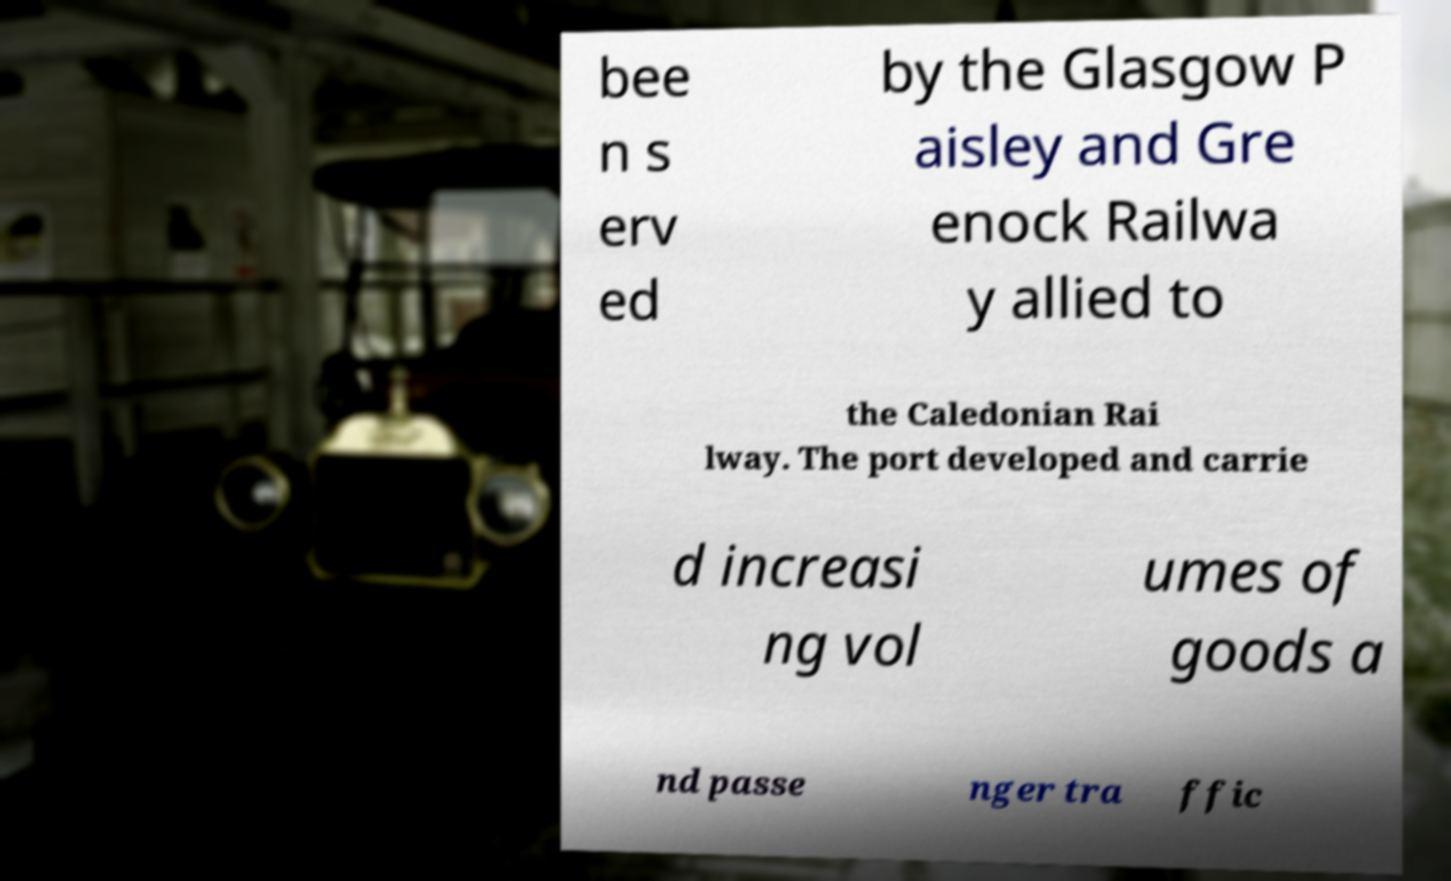Please identify and transcribe the text found in this image. bee n s erv ed by the Glasgow P aisley and Gre enock Railwa y allied to the Caledonian Rai lway. The port developed and carrie d increasi ng vol umes of goods a nd passe nger tra ffic 